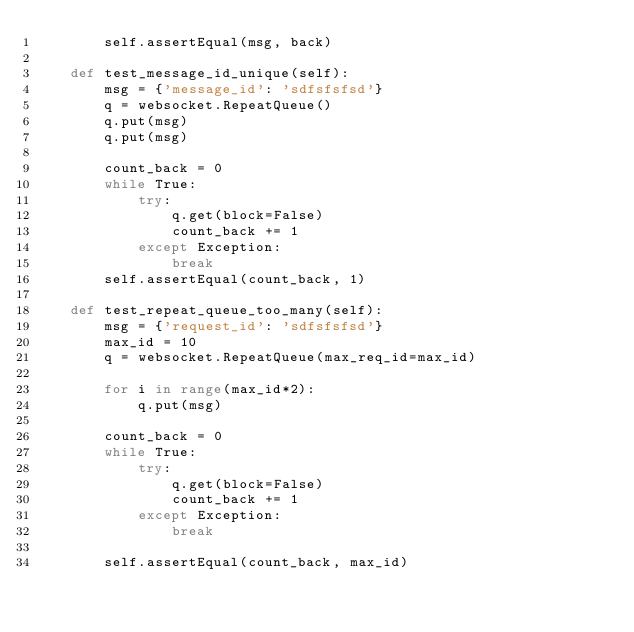Convert code to text. <code><loc_0><loc_0><loc_500><loc_500><_Python_>        self.assertEqual(msg, back)

    def test_message_id_unique(self):
        msg = {'message_id': 'sdfsfsfsd'}
        q = websocket.RepeatQueue()
        q.put(msg)
        q.put(msg)

        count_back = 0
        while True:
            try:
                q.get(block=False)
                count_back += 1
            except Exception:
                break
        self.assertEqual(count_back, 1)

    def test_repeat_queue_too_many(self):
        msg = {'request_id': 'sdfsfsfsd'}
        max_id = 10
        q = websocket.RepeatQueue(max_req_id=max_id)

        for i in range(max_id*2):
            q.put(msg)

        count_back = 0
        while True:
            try:
                q.get(block=False)
                count_back += 1
            except Exception:
                break

        self.assertEqual(count_back, max_id)
</code> 